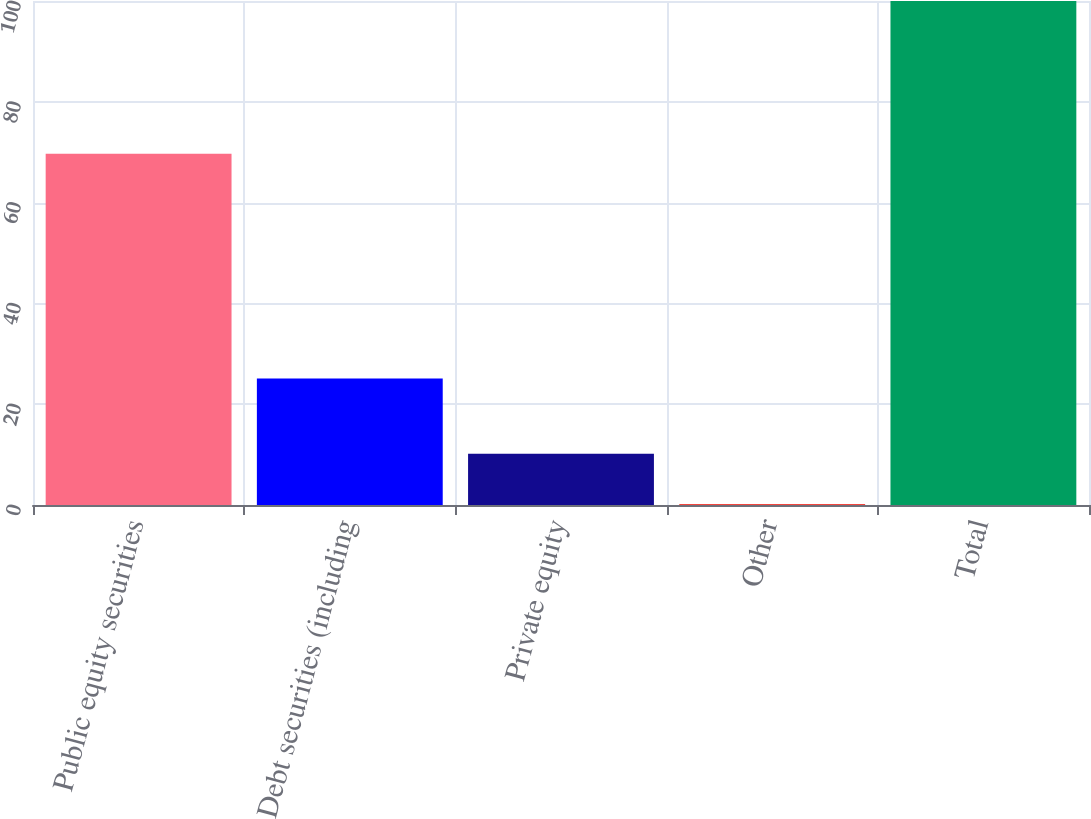Convert chart. <chart><loc_0><loc_0><loc_500><loc_500><bar_chart><fcel>Public equity securities<fcel>Debt securities (including<fcel>Private equity<fcel>Other<fcel>Total<nl><fcel>69.7<fcel>25.1<fcel>10.18<fcel>0.2<fcel>100<nl></chart> 